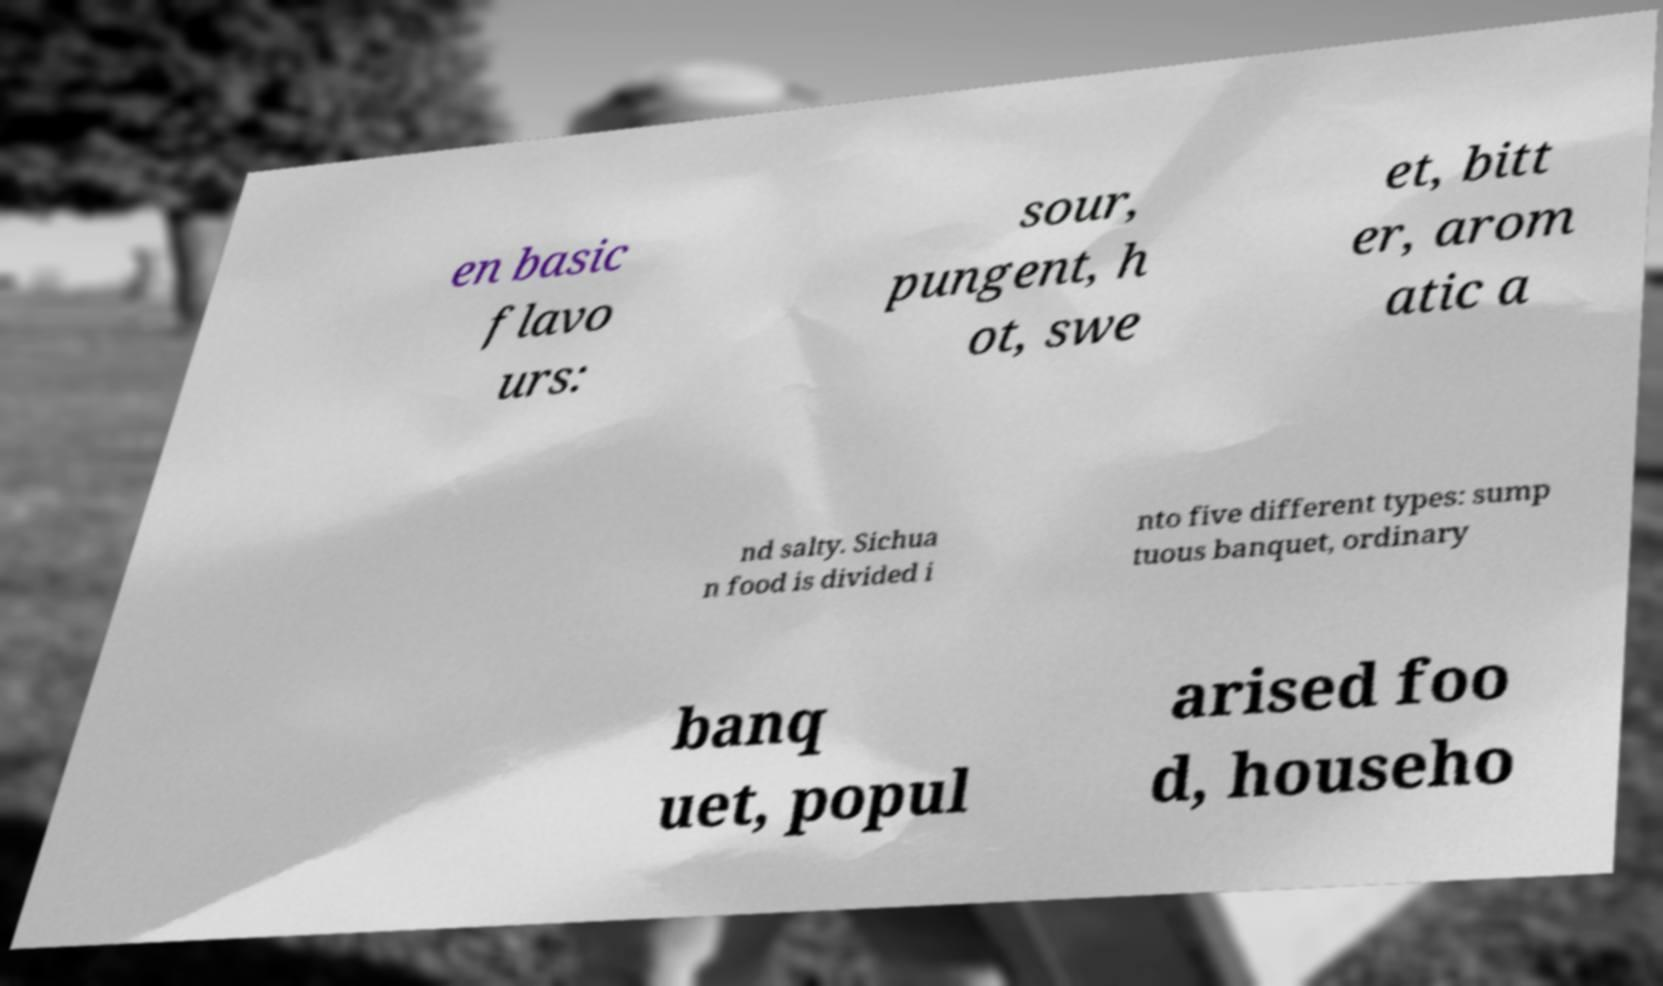Can you read and provide the text displayed in the image?This photo seems to have some interesting text. Can you extract and type it out for me? en basic flavo urs: sour, pungent, h ot, swe et, bitt er, arom atic a nd salty. Sichua n food is divided i nto five different types: sump tuous banquet, ordinary banq uet, popul arised foo d, househo 